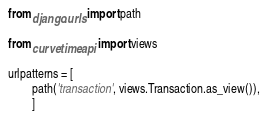<code> <loc_0><loc_0><loc_500><loc_500><_Python_>from django.urls import path

from curvetime.api import views

urlpatterns = [
        path('transaction', views.Transaction.as_view()),
        ]
</code> 